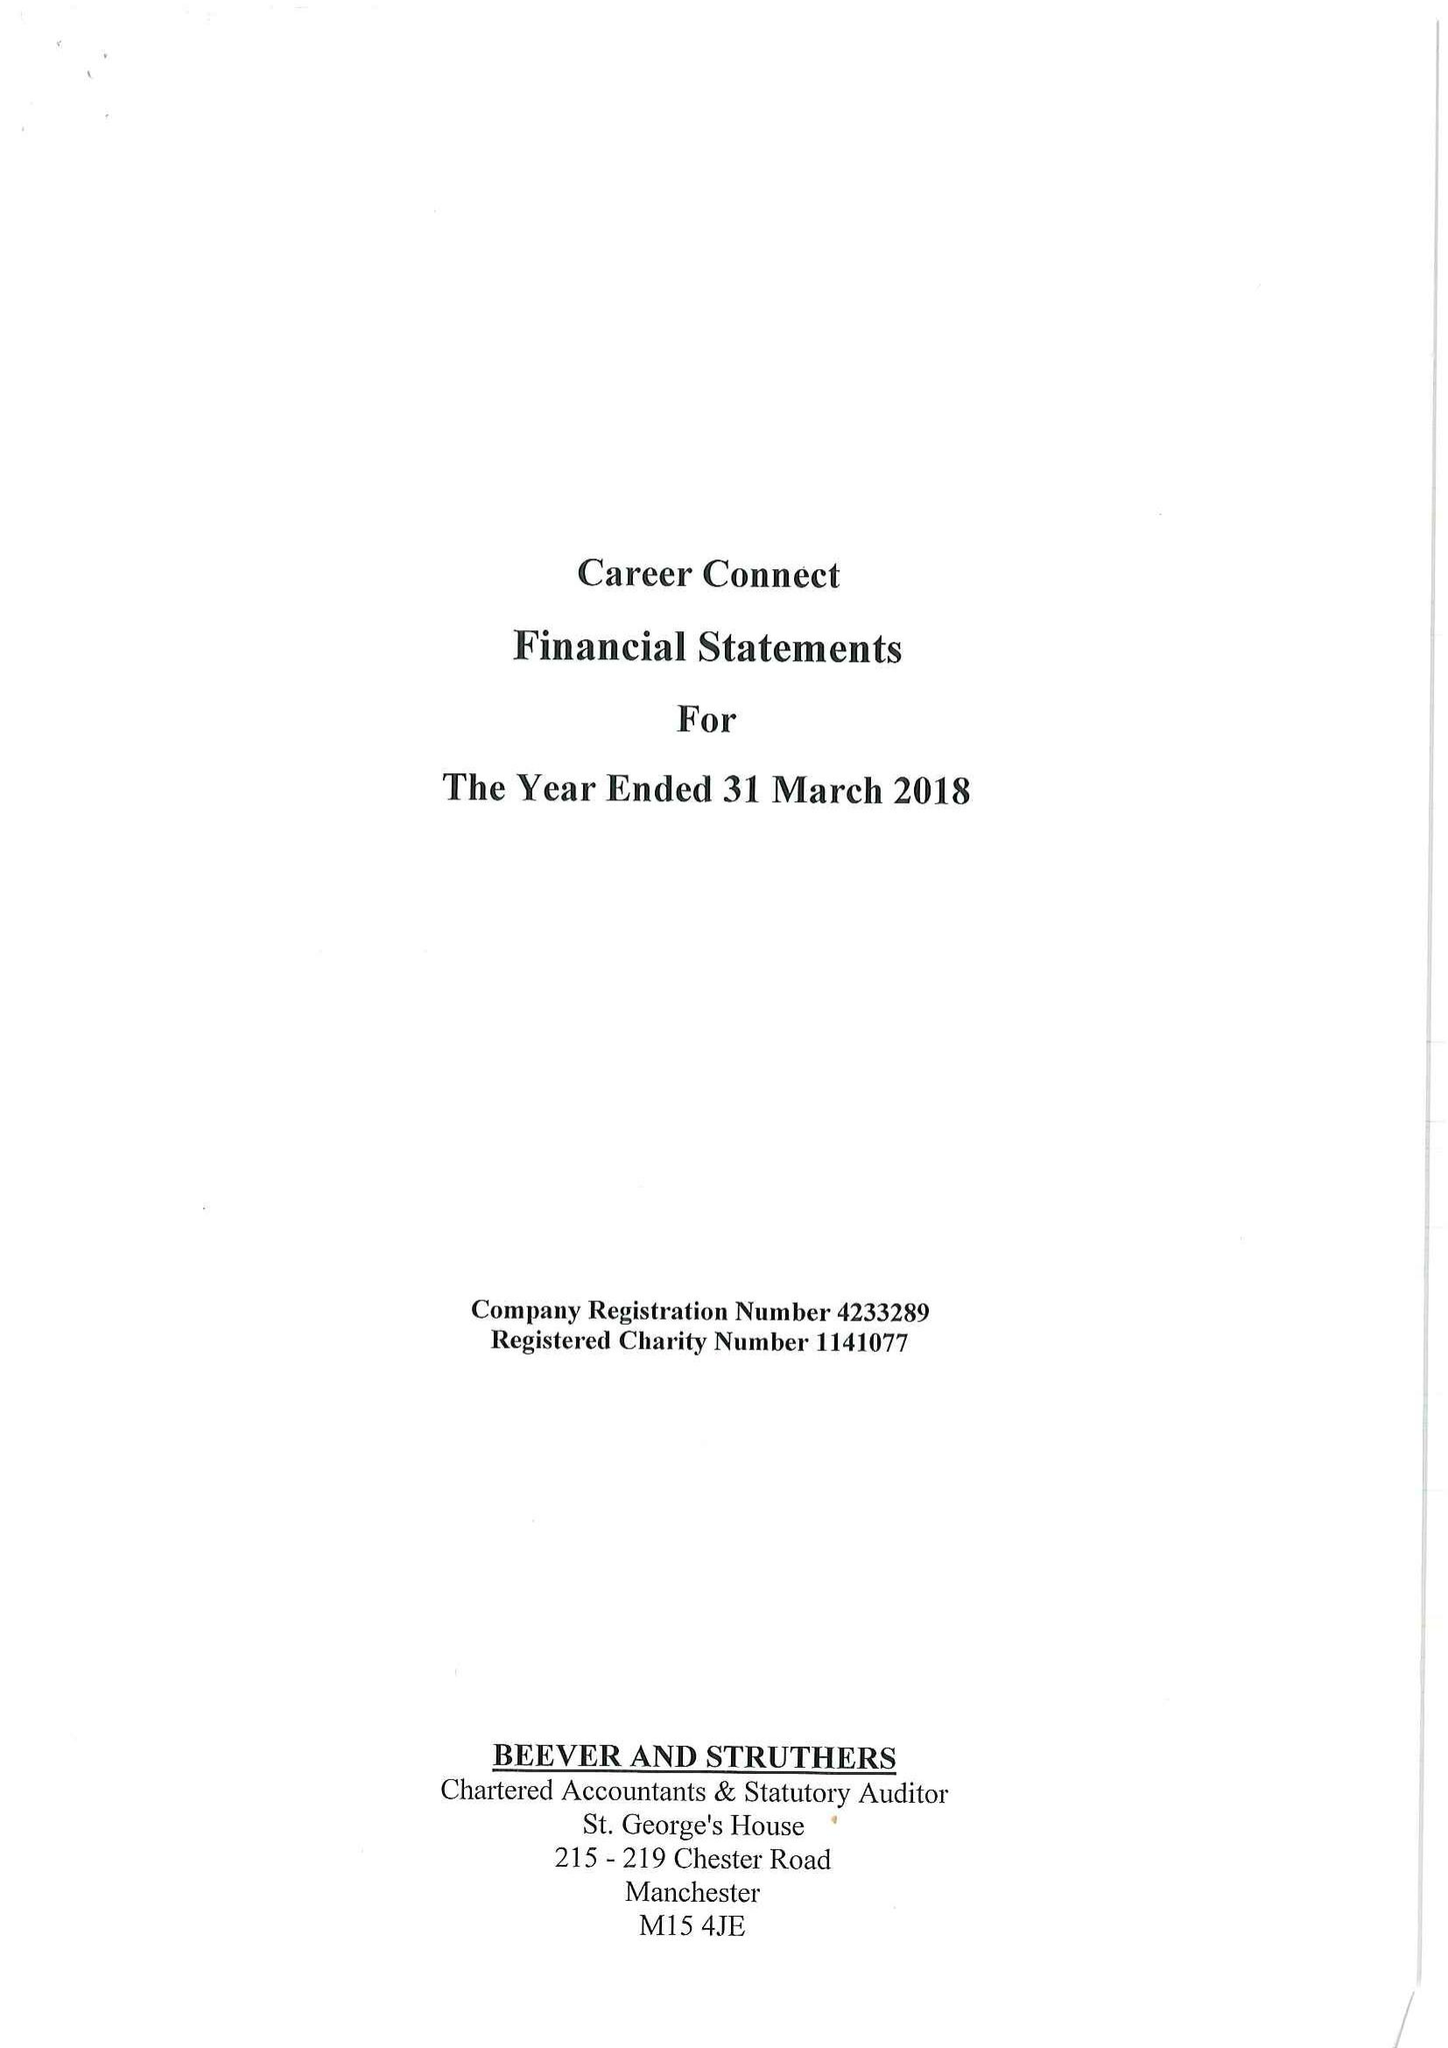What is the value for the spending_annually_in_british_pounds?
Answer the question using a single word or phrase. 15604176.00 